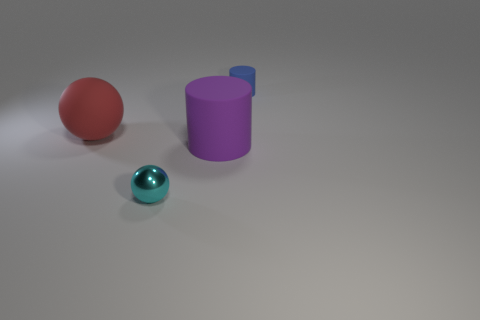Is there a relationship between the objects based on their arrangement? The objects are arranged in a manner that seemingly prioritizes visual balance and contrast. There isn't an obvious functional relationship, but aesthetically, the size gradation from the large red sphere to the small blue one and the positioning of the purple cylinder create a pleasing composition, possibly designed to explore the interplay of shapes and colors in a space. 